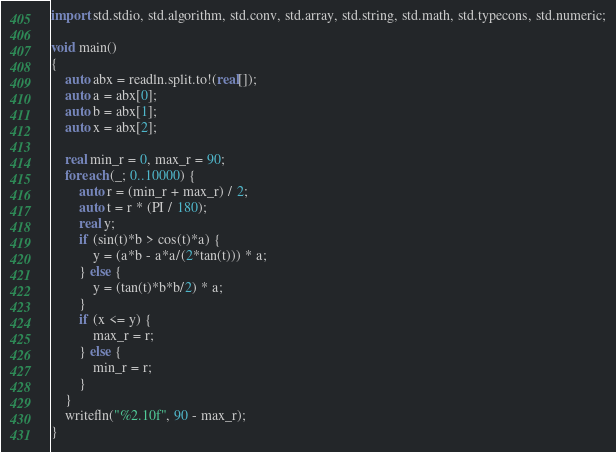Convert code to text. <code><loc_0><loc_0><loc_500><loc_500><_D_>import std.stdio, std.algorithm, std.conv, std.array, std.string, std.math, std.typecons, std.numeric;

void main()
{
    auto abx = readln.split.to!(real[]);
    auto a = abx[0];
    auto b = abx[1];
    auto x = abx[2];

    real min_r = 0, max_r = 90;
    foreach (_; 0..10000) {
        auto r = (min_r + max_r) / 2;
        auto t = r * (PI / 180);
        real y;
        if (sin(t)*b > cos(t)*a) {
            y = (a*b - a*a/(2*tan(t))) * a;
        } else {
            y = (tan(t)*b*b/2) * a;
        }
        if (x <= y) {
            max_r = r;
        } else {
            min_r = r;
        }
    }
    writefln("%2.10f", 90 - max_r);
}</code> 